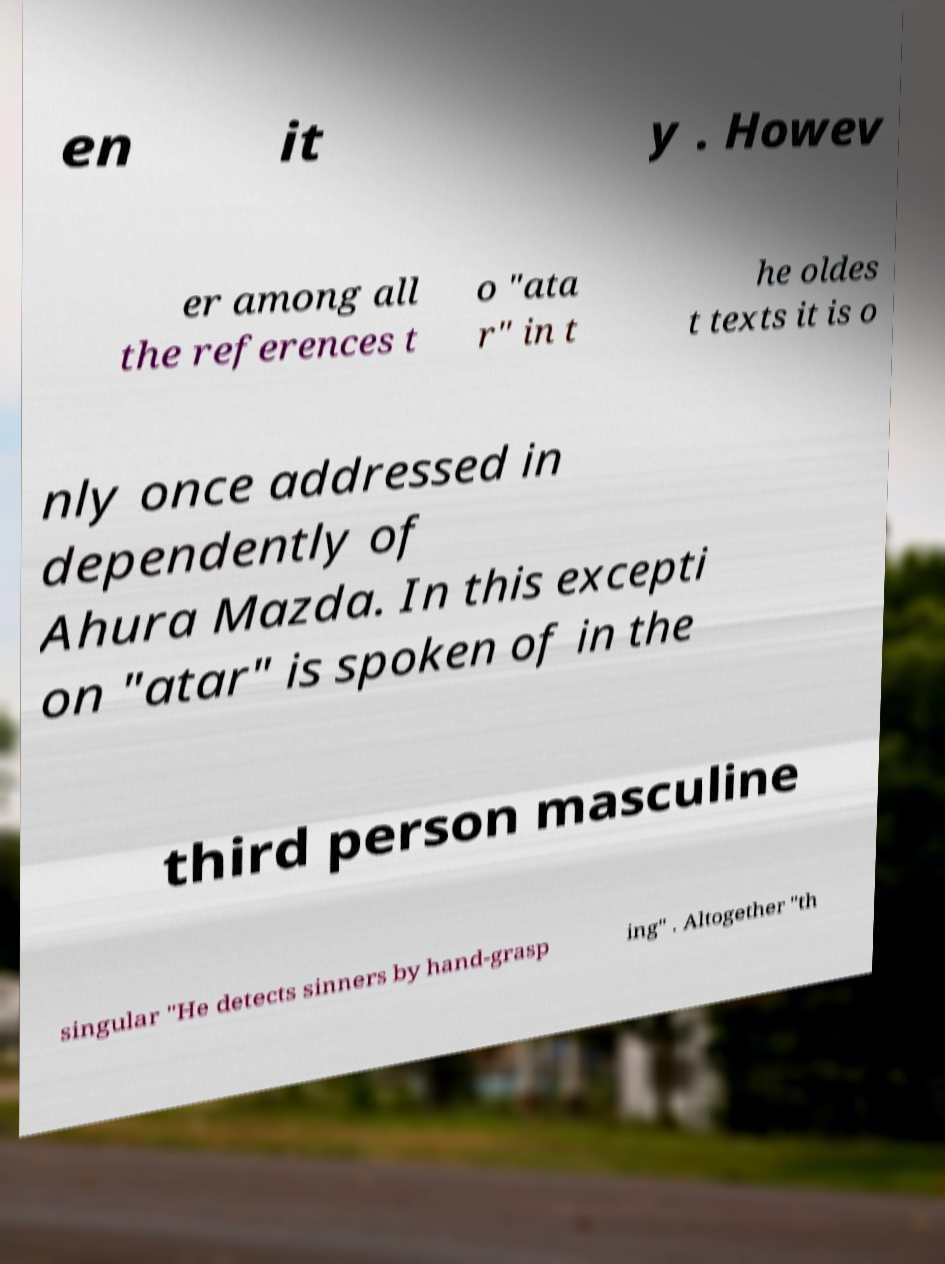Can you accurately transcribe the text from the provided image for me? en it y . Howev er among all the references t o "ata r" in t he oldes t texts it is o nly once addressed in dependently of Ahura Mazda. In this excepti on "atar" is spoken of in the third person masculine singular "He detects sinners by hand-grasp ing" . Altogether "th 